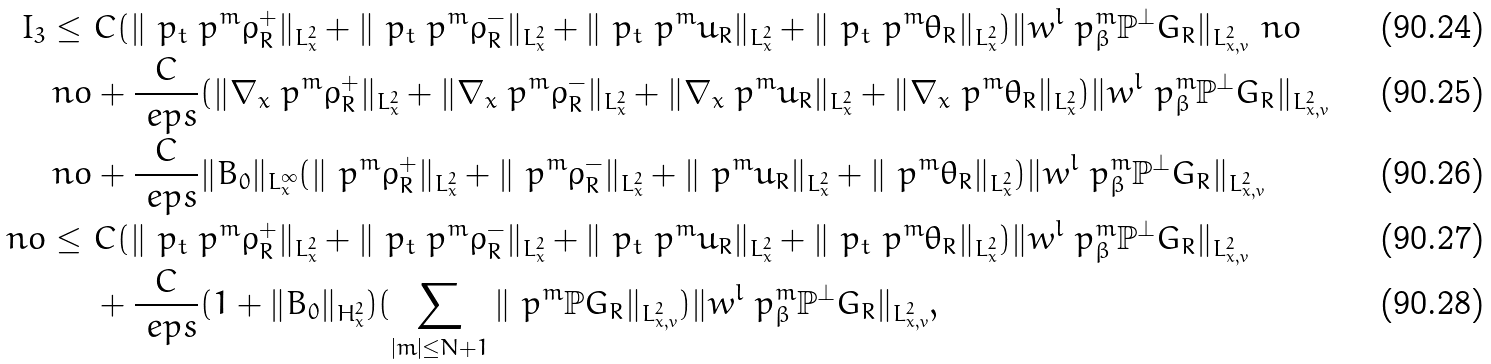<formula> <loc_0><loc_0><loc_500><loc_500>I _ { 3 } \leq \ & C ( \| \ p _ { t } \ p ^ { m } \rho _ { R } ^ { + } \| _ { L ^ { 2 } _ { x } } + \| \ p _ { t } \ p ^ { m } \rho _ { R } ^ { - } \| _ { L ^ { 2 } _ { x } } + \| \ p _ { t } \ p ^ { m } u _ { R } \| _ { L ^ { 2 } _ { x } } + \| \ p _ { t } \ p ^ { m } \theta _ { R } \| _ { L ^ { 2 } _ { x } } ) \| w ^ { l } \ p ^ { m } _ { \beta } \mathbb { P } ^ { \perp } G _ { R } \| _ { L ^ { 2 } _ { x , v } } \ n o \\ \ n o & + \frac { C } { \ e p s } ( \| \nabla _ { x } \ p ^ { m } \rho _ { R } ^ { + } \| _ { L ^ { 2 } _ { x } } + \| \nabla _ { x } \ p ^ { m } \rho _ { R } ^ { - } \| _ { L ^ { 2 } _ { x } } + \| \nabla _ { x } \ p ^ { m } u _ { R } \| _ { L ^ { 2 } _ { x } } + \| \nabla _ { x } \ p ^ { m } \theta _ { R } \| _ { L ^ { 2 } _ { x } } ) \| w ^ { l } \ p ^ { m } _ { \beta } \mathbb { P } ^ { \perp } G _ { R } \| _ { L ^ { 2 } _ { x , v } } \\ \ n o & + \frac { C } { \ e p s } \| B _ { 0 } \| _ { L ^ { \infty } _ { x } } ( \| \ p ^ { m } \rho _ { R } ^ { + } \| _ { L ^ { 2 } _ { x } } + \| \ p ^ { m } \rho _ { R } ^ { - } \| _ { L ^ { 2 } _ { x } } + \| \ p ^ { m } u _ { R } \| _ { L ^ { 2 } _ { x } } + \| \ p ^ { m } \theta _ { R } \| _ { L ^ { 2 } _ { x } } ) \| w ^ { l } \ p ^ { m } _ { \beta } \mathbb { P } ^ { \perp } G _ { R } \| _ { L ^ { 2 } _ { x , v } } \\ \ n o \leq \ & C ( \| \ p _ { t } \ p ^ { m } \rho _ { R } ^ { + } \| _ { L ^ { 2 } _ { x } } + \| \ p _ { t } \ p ^ { m } \rho _ { R } ^ { - } \| _ { L ^ { 2 } _ { x } } + \| \ p _ { t } \ p ^ { m } u _ { R } \| _ { L ^ { 2 } _ { x } } + \| \ p _ { t } \ p ^ { m } \theta _ { R } \| _ { L ^ { 2 } _ { x } } ) \| w ^ { l } \ p ^ { m } _ { \beta } \mathbb { P } ^ { \perp } G _ { R } \| _ { L ^ { 2 } _ { x , v } } \\ & + \frac { C } { \ e p s } ( 1 + \| B _ { 0 } \| _ { H ^ { 2 } _ { x } } ) ( \sum _ { | m | \leq N + 1 } \| \ p ^ { m } \mathbb { P } G _ { R } \| _ { L ^ { 2 } _ { x , v } } ) \| w ^ { l } \ p ^ { m } _ { \beta } \mathbb { P } ^ { \perp } G _ { R } \| _ { L ^ { 2 } _ { x , v } } ,</formula> 